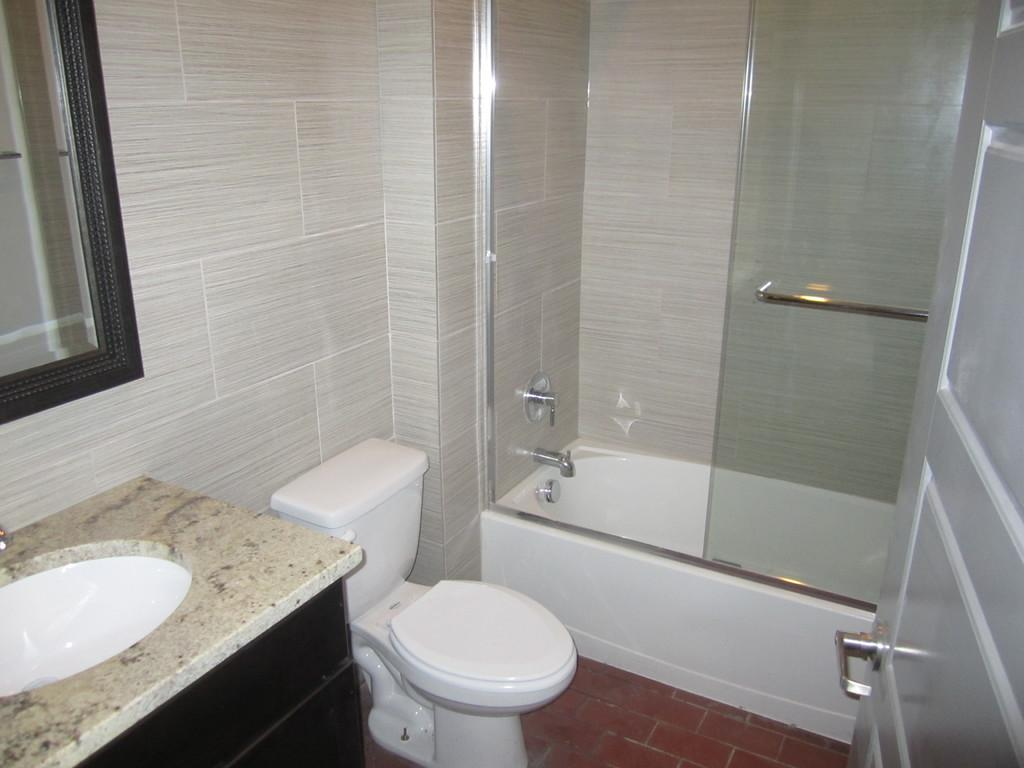What type of toilet is visible in the image? There is a white color western toilet in the image. What other bathroom fixture can be seen in the image? There is a bath tub in the image. Where is the wash basin located in the image? The wash basin is on the left side of the image. What is used for personal grooming in the image? There is a mirror in the image for personal grooming. What type of rule is being enforced in the bathroom according to the image? There is no rule being enforced in the image; it simply shows a bathroom with various fixtures. What color is the goat that is present in the image? There is no goat present in the image. 